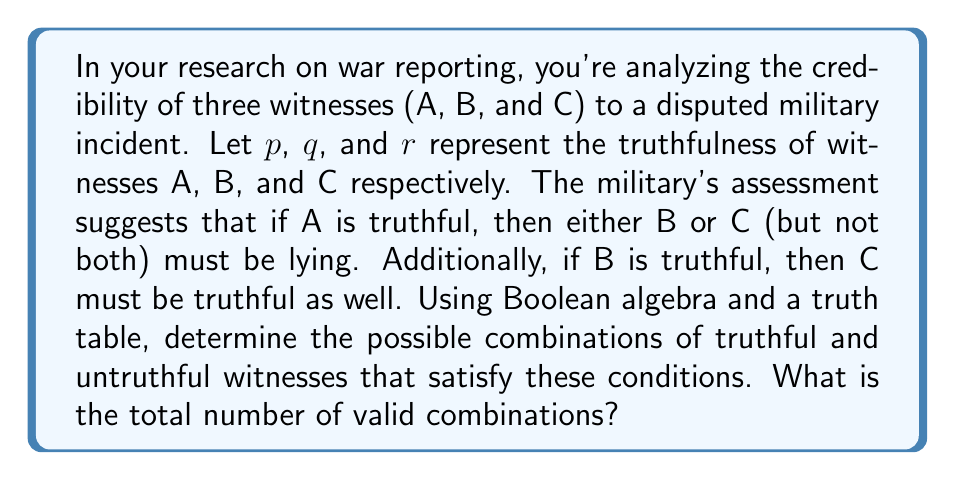What is the answer to this math problem? Let's approach this step-by-step using Boolean algebra and a truth table:

1) First, we need to translate the given conditions into Boolean expressions:
   - If A is truthful, then either B or C (but not both) must be lying: $p \rightarrow (q \oplus r)$
   - If B is truthful, then C must be truthful: $q \rightarrow r$

2) We can combine these conditions using the AND operator:
   $$(p \rightarrow (q \oplus r)) \wedge (q \rightarrow r)$$

3) Now, let's create a truth table for this expression:

   | $p$ | $q$ | $r$ | $q \oplus r$ | $p \rightarrow (q \oplus r)$ | $q \rightarrow r$ | Result |
   |-----|-----|-----|--------------|------------------------------|-------------------|--------|
   | 0   | 0   | 0   | 0            | 1                            | 1                 | 1      |
   | 0   | 0   | 1   | 1            | 1                            | 1                 | 1      |
   | 0   | 1   | 0   | 1            | 1                            | 0                 | 0      |
   | 0   | 1   | 1   | 0            | 1                            | 1                 | 1      |
   | 1   | 0   | 0   | 0            | 0                            | 1                 | 0      |
   | 1   | 0   | 1   | 1            | 1                            | 1                 | 1      |
   | 1   | 1   | 0   | 1            | 1                            | 0                 | 0      |
   | 1   | 1   | 1   | 0            | 0                            | 1                 | 0      |

4) The valid combinations are those where the Result column is 1.

5) Counting the number of 1s in the Result column, we find 3 valid combinations.

These combinations represent:
- All witnesses lying (0,0,0)
- Only C telling the truth (0,0,1)
- A and C telling the truth, B lying (1,0,1)
Answer: 3 